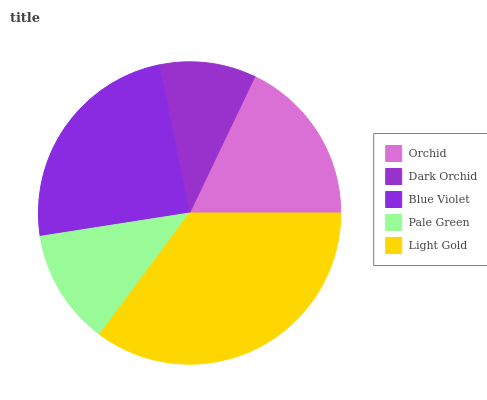Is Dark Orchid the minimum?
Answer yes or no. Yes. Is Light Gold the maximum?
Answer yes or no. Yes. Is Blue Violet the minimum?
Answer yes or no. No. Is Blue Violet the maximum?
Answer yes or no. No. Is Blue Violet greater than Dark Orchid?
Answer yes or no. Yes. Is Dark Orchid less than Blue Violet?
Answer yes or no. Yes. Is Dark Orchid greater than Blue Violet?
Answer yes or no. No. Is Blue Violet less than Dark Orchid?
Answer yes or no. No. Is Orchid the high median?
Answer yes or no. Yes. Is Orchid the low median?
Answer yes or no. Yes. Is Pale Green the high median?
Answer yes or no. No. Is Blue Violet the low median?
Answer yes or no. No. 